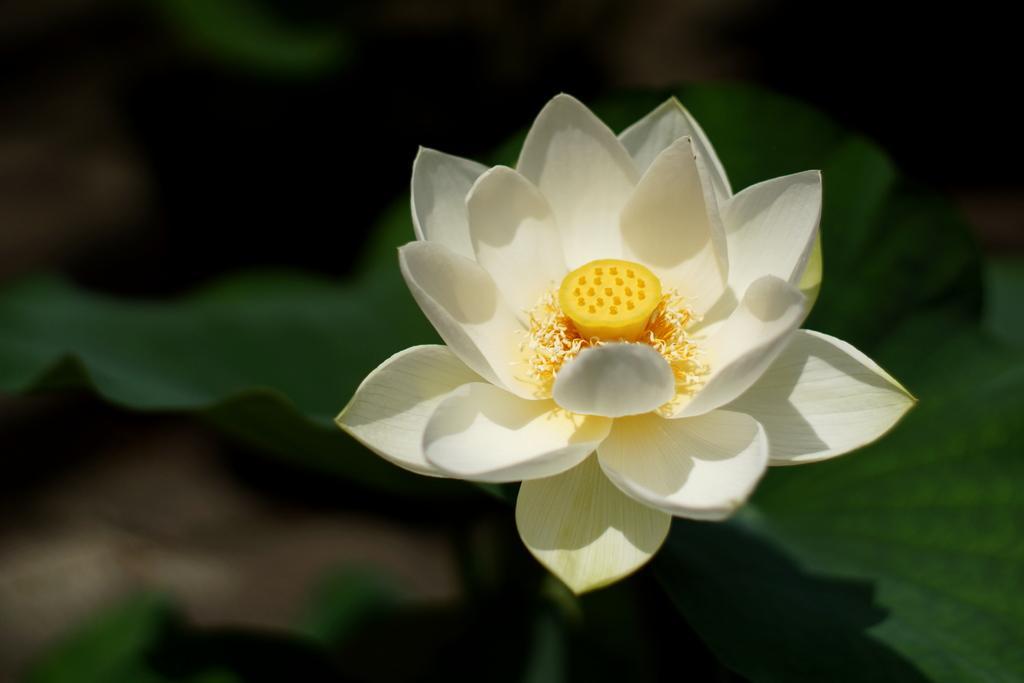Can you describe this image briefly? There is a white color flower present in the middle of this image. 